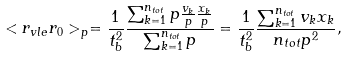<formula> <loc_0><loc_0><loc_500><loc_500>< r _ { v l e } r _ { 0 } > _ { p } = \frac { 1 } { t _ { b } ^ { 2 } } \frac { \sum _ { k = 1 } ^ { n _ { t o t } } p \frac { v _ { k } } { p } \frac { x _ { k } } { p } } { \sum _ { k = 1 } ^ { n _ { t o t } } p } = \frac { 1 } { t _ { b } ^ { 2 } } \frac { \sum _ { k = 1 } ^ { n _ { t o t } } v _ { k } x _ { k } } { n _ { t o t } p ^ { 2 } } ,</formula> 